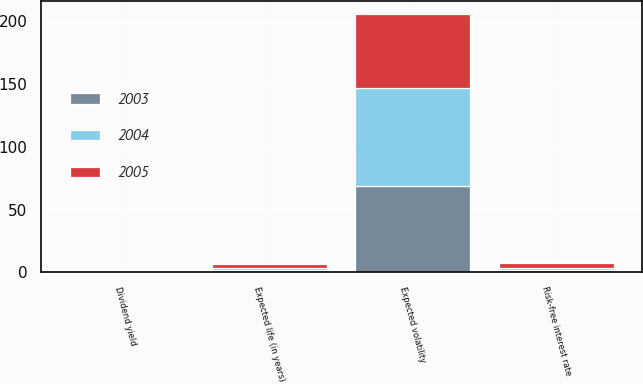<chart> <loc_0><loc_0><loc_500><loc_500><stacked_bar_chart><ecel><fcel>Dividend yield<fcel>Expected volatility<fcel>Risk-free interest rate<fcel>Expected life (in years)<nl><fcel>2003<fcel>0<fcel>69<fcel>1.59<fcel>1.95<nl><fcel>2004<fcel>0<fcel>78<fcel>2.23<fcel>1.85<nl><fcel>2005<fcel>0<fcel>59<fcel>3.67<fcel>3.08<nl></chart> 